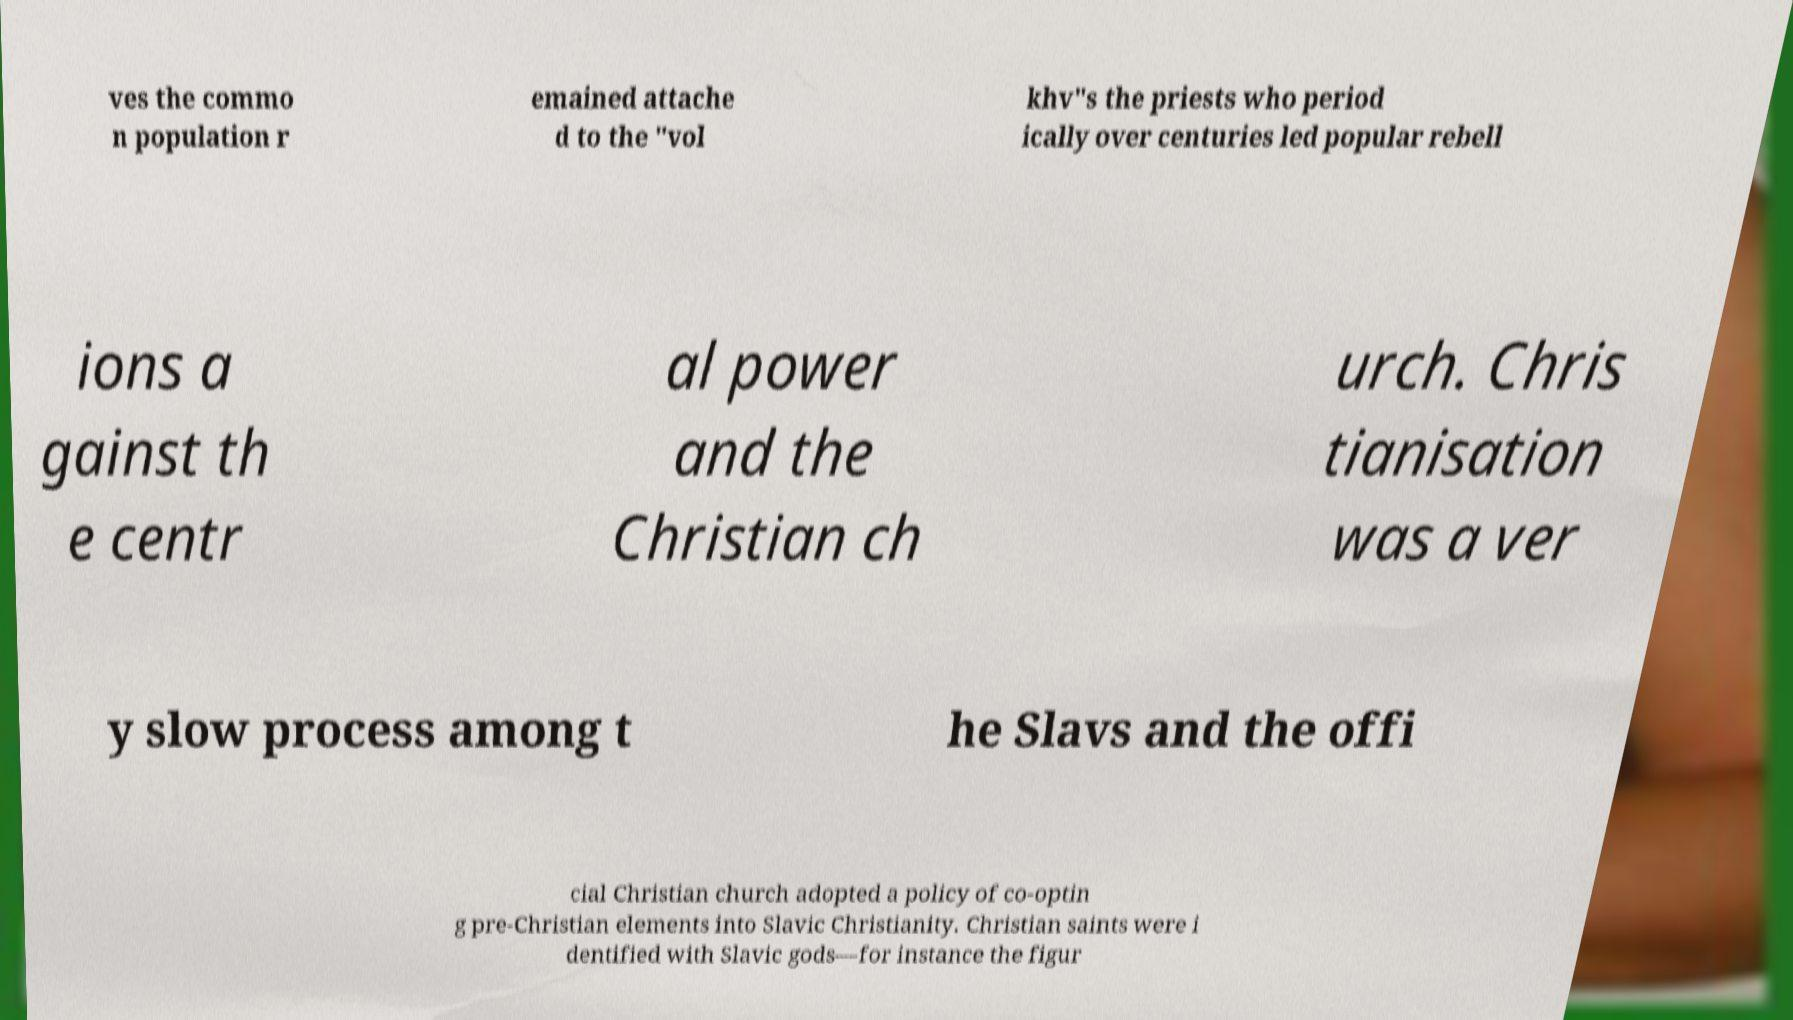Could you extract and type out the text from this image? ves the commo n population r emained attache d to the "vol khv"s the priests who period ically over centuries led popular rebell ions a gainst th e centr al power and the Christian ch urch. Chris tianisation was a ver y slow process among t he Slavs and the offi cial Christian church adopted a policy of co-optin g pre-Christian elements into Slavic Christianity. Christian saints were i dentified with Slavic gods—for instance the figur 